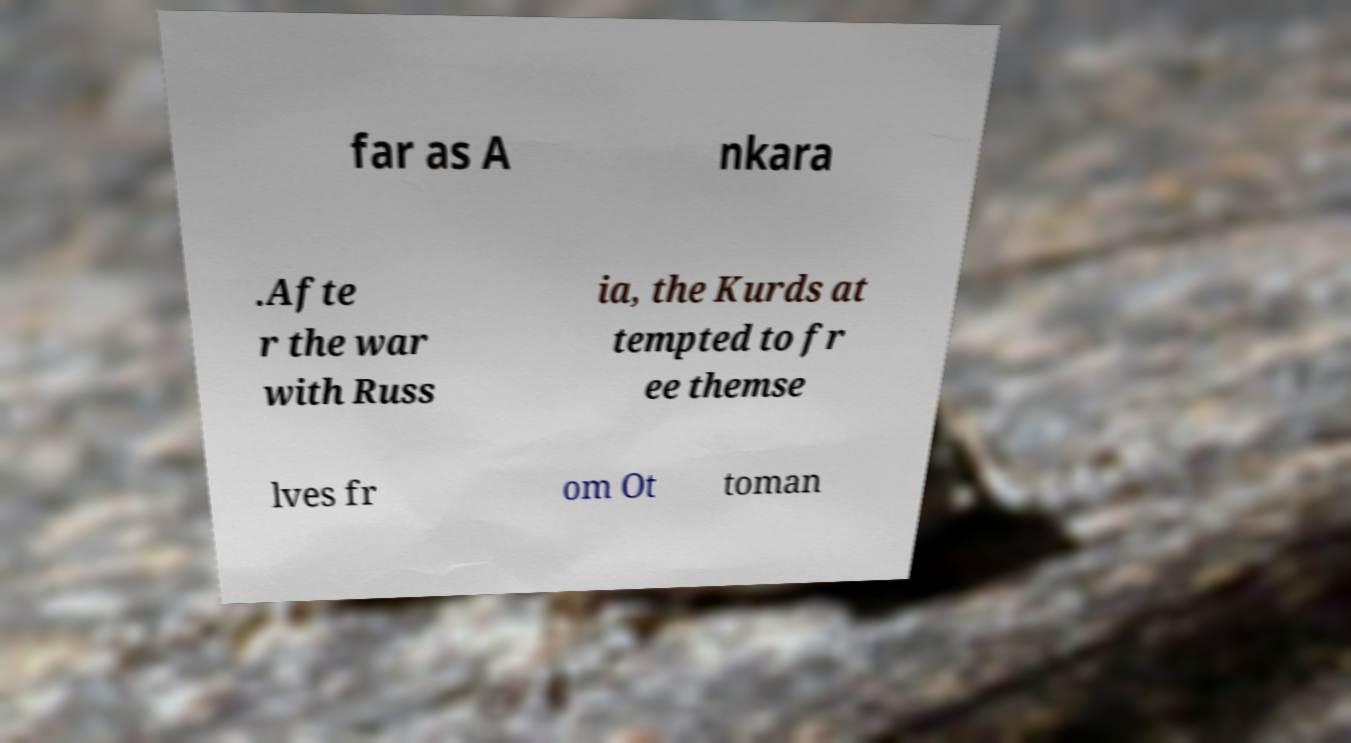I need the written content from this picture converted into text. Can you do that? far as A nkara .Afte r the war with Russ ia, the Kurds at tempted to fr ee themse lves fr om Ot toman 